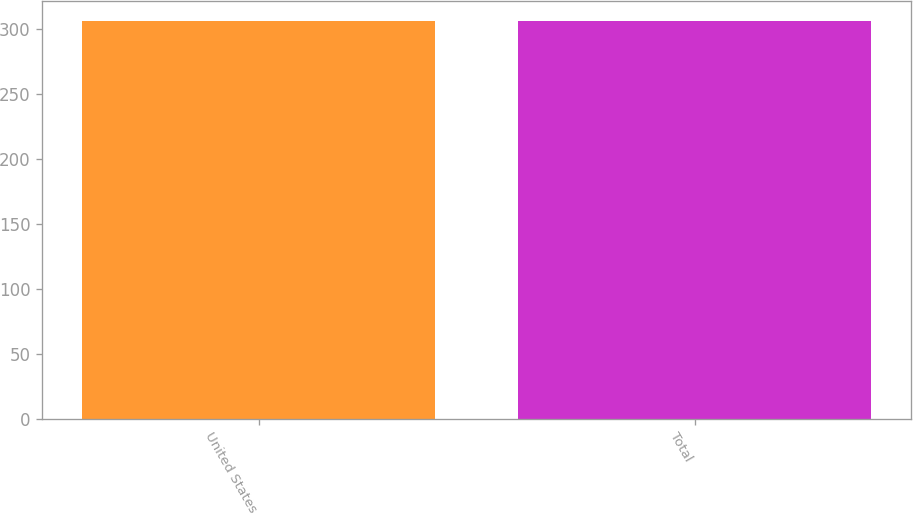Convert chart to OTSL. <chart><loc_0><loc_0><loc_500><loc_500><bar_chart><fcel>United States<fcel>Total<nl><fcel>306<fcel>306.1<nl></chart> 